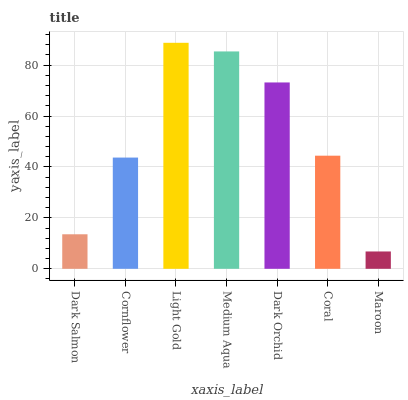Is Maroon the minimum?
Answer yes or no. Yes. Is Light Gold the maximum?
Answer yes or no. Yes. Is Cornflower the minimum?
Answer yes or no. No. Is Cornflower the maximum?
Answer yes or no. No. Is Cornflower greater than Dark Salmon?
Answer yes or no. Yes. Is Dark Salmon less than Cornflower?
Answer yes or no. Yes. Is Dark Salmon greater than Cornflower?
Answer yes or no. No. Is Cornflower less than Dark Salmon?
Answer yes or no. No. Is Coral the high median?
Answer yes or no. Yes. Is Coral the low median?
Answer yes or no. Yes. Is Cornflower the high median?
Answer yes or no. No. Is Cornflower the low median?
Answer yes or no. No. 